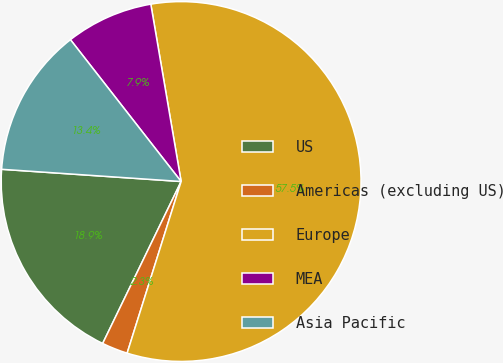<chart> <loc_0><loc_0><loc_500><loc_500><pie_chart><fcel>US<fcel>Americas (excluding US)<fcel>Europe<fcel>MEA<fcel>Asia Pacific<nl><fcel>18.9%<fcel>2.33%<fcel>57.54%<fcel>7.85%<fcel>13.37%<nl></chart> 